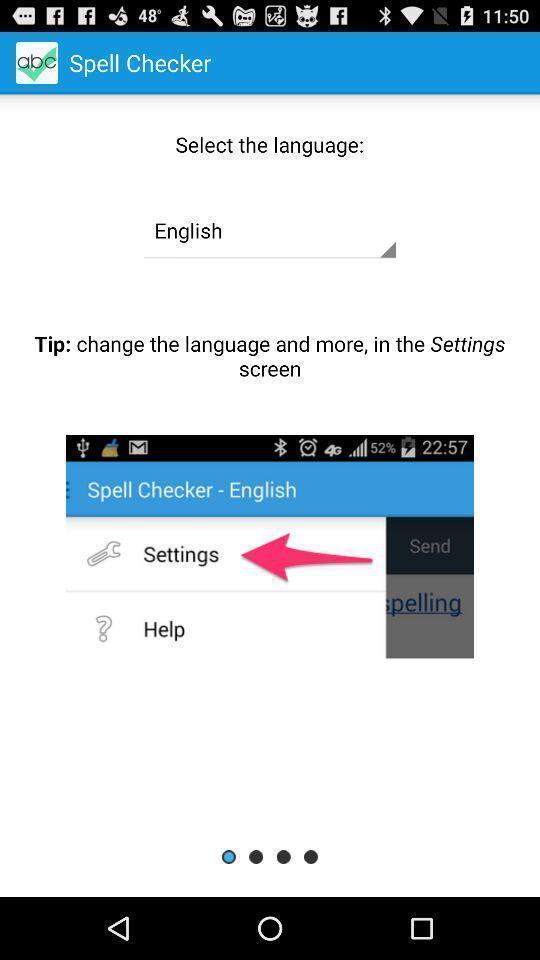What is the overall content of this screenshot? Screen displaying to select language. 